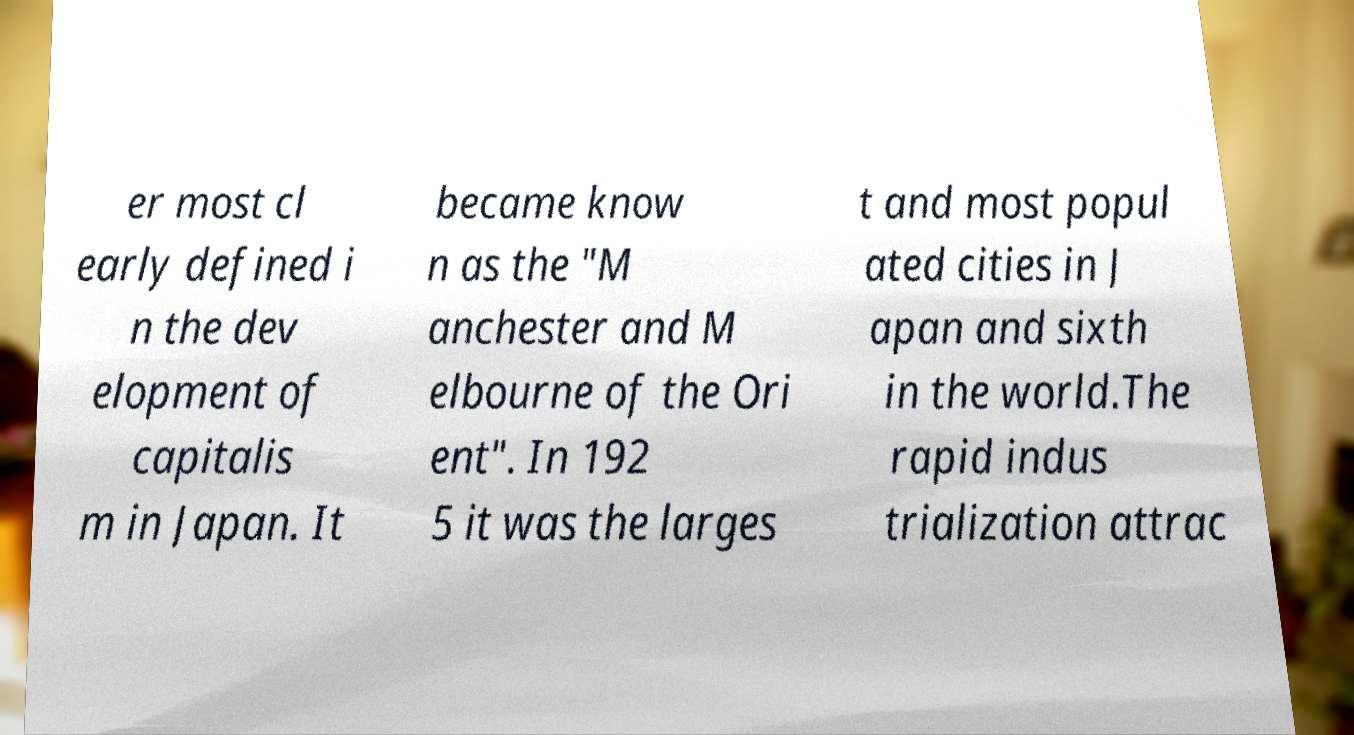I need the written content from this picture converted into text. Can you do that? er most cl early defined i n the dev elopment of capitalis m in Japan. It became know n as the "M anchester and M elbourne of the Ori ent". In 192 5 it was the larges t and most popul ated cities in J apan and sixth in the world.The rapid indus trialization attrac 